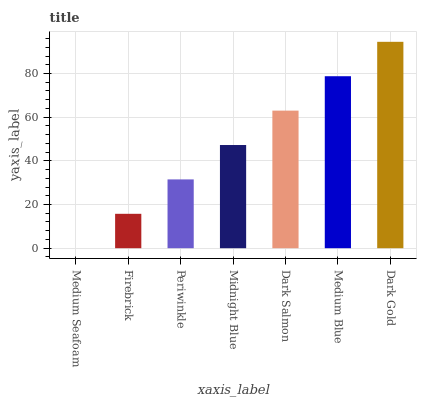Is Firebrick the minimum?
Answer yes or no. No. Is Firebrick the maximum?
Answer yes or no. No. Is Firebrick greater than Medium Seafoam?
Answer yes or no. Yes. Is Medium Seafoam less than Firebrick?
Answer yes or no. Yes. Is Medium Seafoam greater than Firebrick?
Answer yes or no. No. Is Firebrick less than Medium Seafoam?
Answer yes or no. No. Is Midnight Blue the high median?
Answer yes or no. Yes. Is Midnight Blue the low median?
Answer yes or no. Yes. Is Firebrick the high median?
Answer yes or no. No. Is Periwinkle the low median?
Answer yes or no. No. 